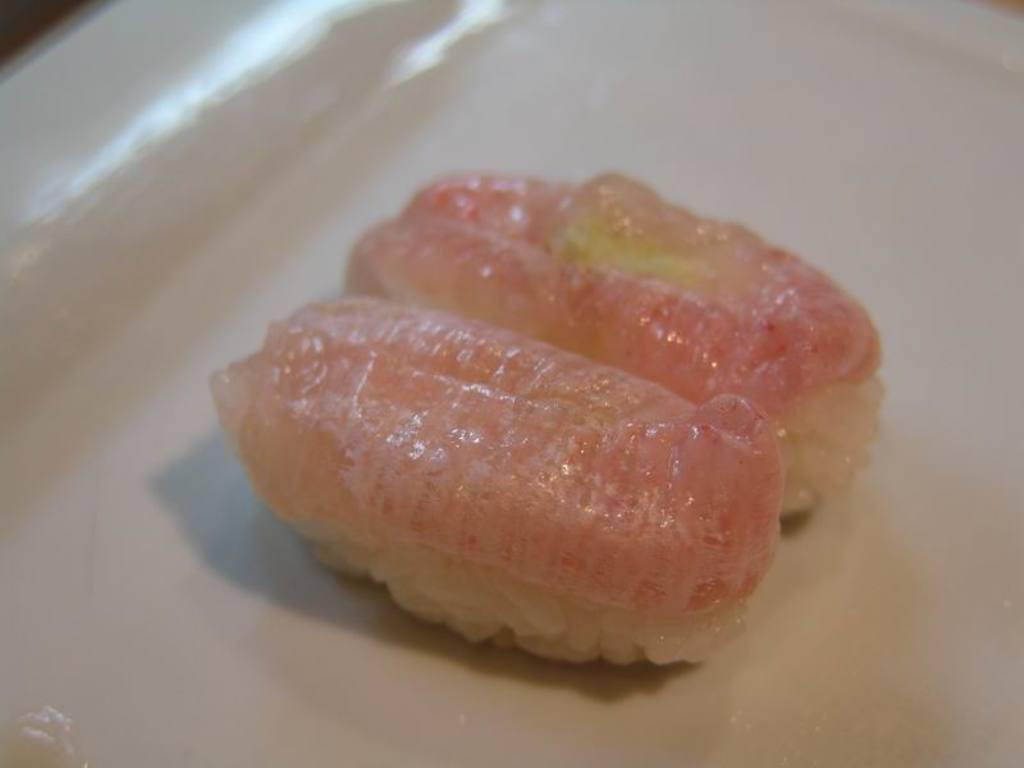What is present on the plate in the image? There are food items on a plate in the image. How many oranges are on the plate in the image? There is no orange present on the plate in the image. What type of things are crawling on the plate in the image? There are no things crawling on the plate in the image. 